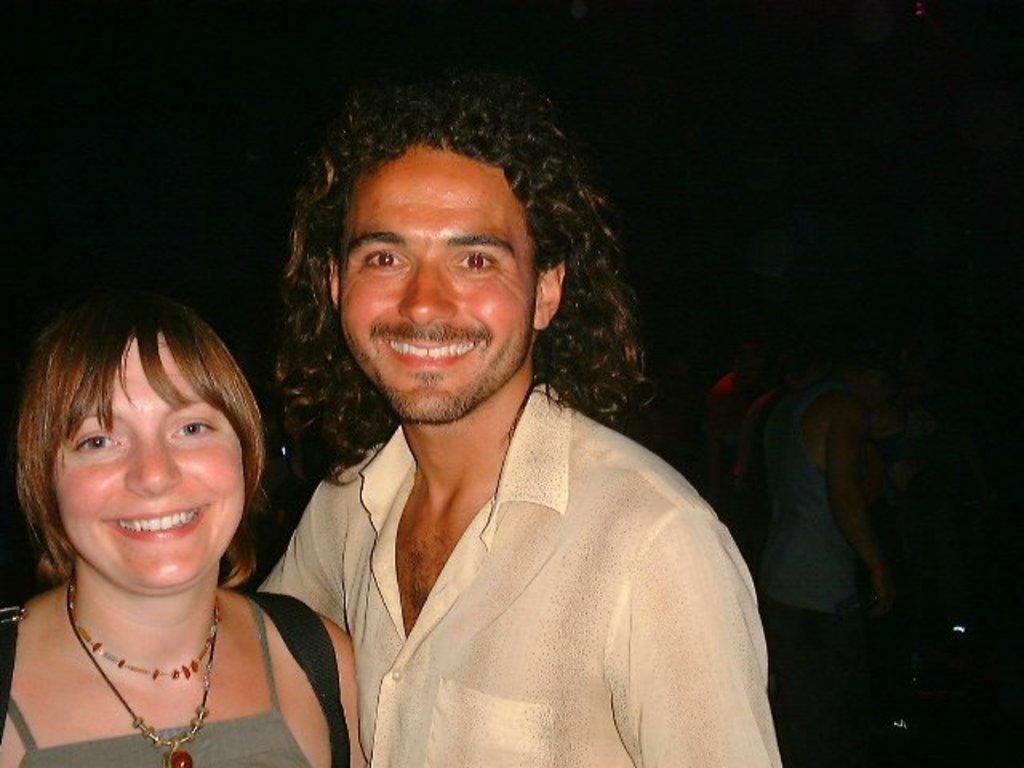How many people are in the image? There are two people in the image, a man and a woman. What are the man and the woman doing in the image? Both the man and the woman are standing, and they are smiling. What can be observed about the background of the image? The background of the image is dark. What type of tramp can be seen in the image? There is no tramp present in the image; it features a man and a woman standing and smiling. What is the woman carrying in a sack in the image? There is no sack or any item being carried by the woman in the image. 